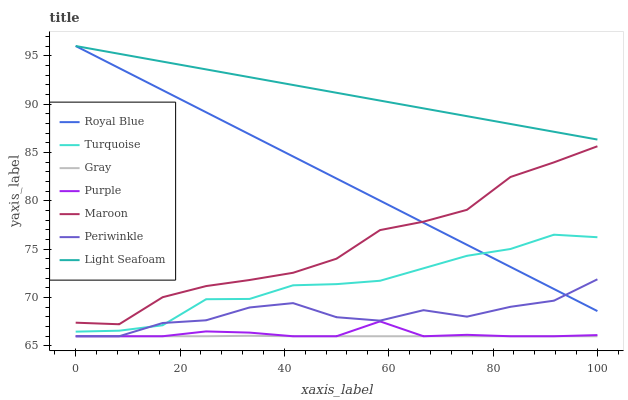Does Gray have the minimum area under the curve?
Answer yes or no. Yes. Does Light Seafoam have the maximum area under the curve?
Answer yes or no. Yes. Does Turquoise have the minimum area under the curve?
Answer yes or no. No. Does Turquoise have the maximum area under the curve?
Answer yes or no. No. Is Light Seafoam the smoothest?
Answer yes or no. Yes. Is Periwinkle the roughest?
Answer yes or no. Yes. Is Turquoise the smoothest?
Answer yes or no. No. Is Turquoise the roughest?
Answer yes or no. No. Does Gray have the lowest value?
Answer yes or no. Yes. Does Turquoise have the lowest value?
Answer yes or no. No. Does Light Seafoam have the highest value?
Answer yes or no. Yes. Does Turquoise have the highest value?
Answer yes or no. No. Is Maroon less than Light Seafoam?
Answer yes or no. Yes. Is Light Seafoam greater than Periwinkle?
Answer yes or no. Yes. Does Purple intersect Periwinkle?
Answer yes or no. Yes. Is Purple less than Periwinkle?
Answer yes or no. No. Is Purple greater than Periwinkle?
Answer yes or no. No. Does Maroon intersect Light Seafoam?
Answer yes or no. No. 